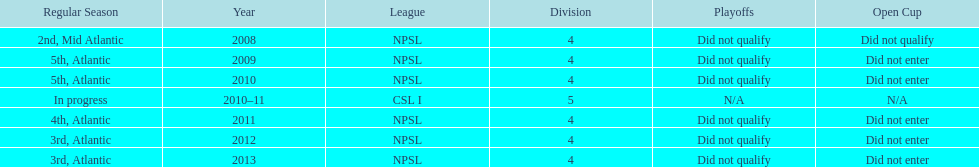What is the only year that is n/a? 2010-11. Would you mind parsing the complete table? {'header': ['Regular Season', 'Year', 'League', 'Division', 'Playoffs', 'Open Cup'], 'rows': [['2nd, Mid Atlantic', '2008', 'NPSL', '4', 'Did not qualify', 'Did not qualify'], ['5th, Atlantic', '2009', 'NPSL', '4', 'Did not qualify', 'Did not enter'], ['5th, Atlantic', '2010', 'NPSL', '4', 'Did not qualify', 'Did not enter'], ['In progress', '2010–11', 'CSL I', '5', 'N/A', 'N/A'], ['4th, Atlantic', '2011', 'NPSL', '4', 'Did not qualify', 'Did not enter'], ['3rd, Atlantic', '2012', 'NPSL', '4', 'Did not qualify', 'Did not enter'], ['3rd, Atlantic', '2013', 'NPSL', '4', 'Did not qualify', 'Did not enter']]} 